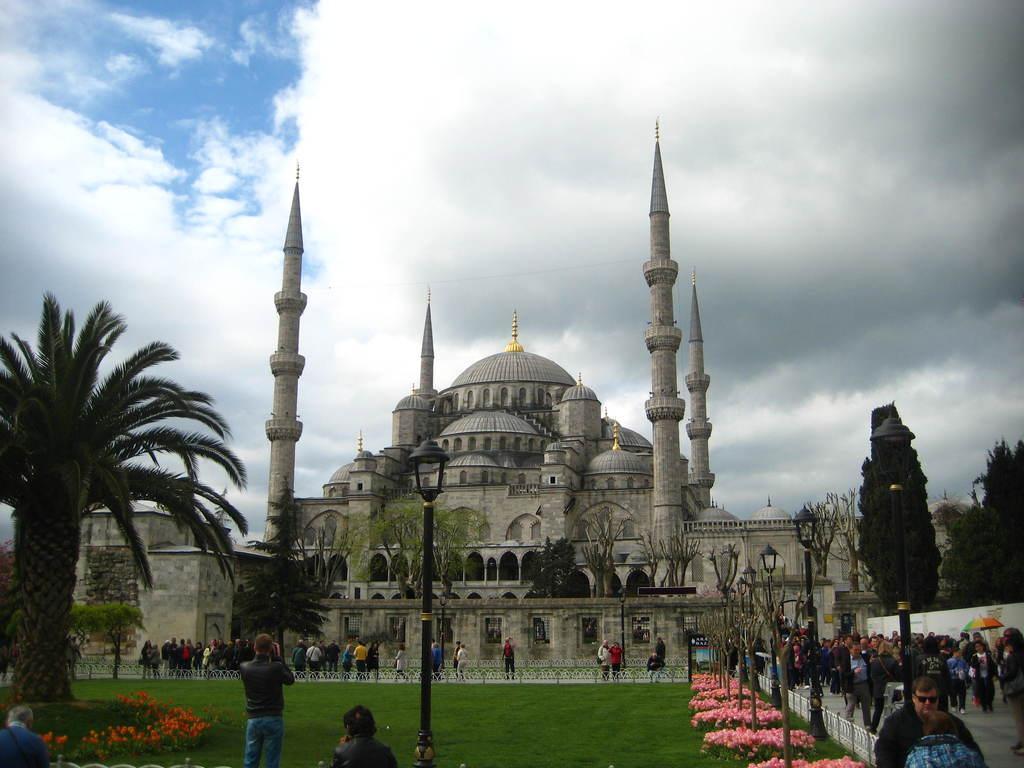Describe this image in one or two sentences. This image is taken outdoors. At the top of the image there is the sky with clouds. At the bottom of the image there is a ground with grass on it and there are a few people standing on the ground. In the middle of the image there is an architecture. There are few trees and plants with leaves, stems and branches. There is a pole with a street light. Many people are walking on the floor and a few are standing. There is a railing. 